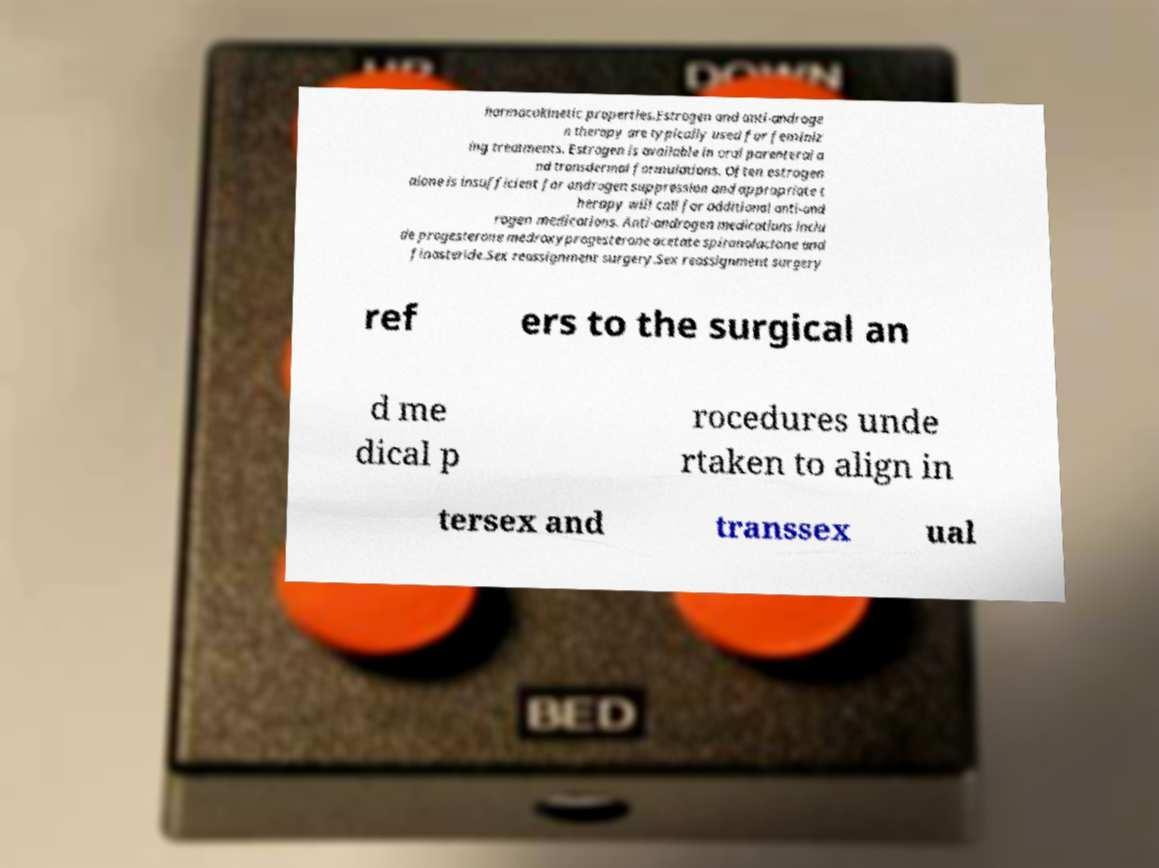Please read and relay the text visible in this image. What does it say? harmacokinetic properties.Estrogen and anti-androge n therapy are typically used for feminiz ing treatments. Estrogen is available in oral parenteral a nd transdermal formulations. Often estrogen alone is insufficient for androgen suppression and appropriate t herapy will call for additional anti-and rogen medications. Anti-androgen medications inclu de progesterone medroxyprogesterone acetate spironolactone and finasteride.Sex reassignment surgery.Sex reassignment surgery ref ers to the surgical an d me dical p rocedures unde rtaken to align in tersex and transsex ual 